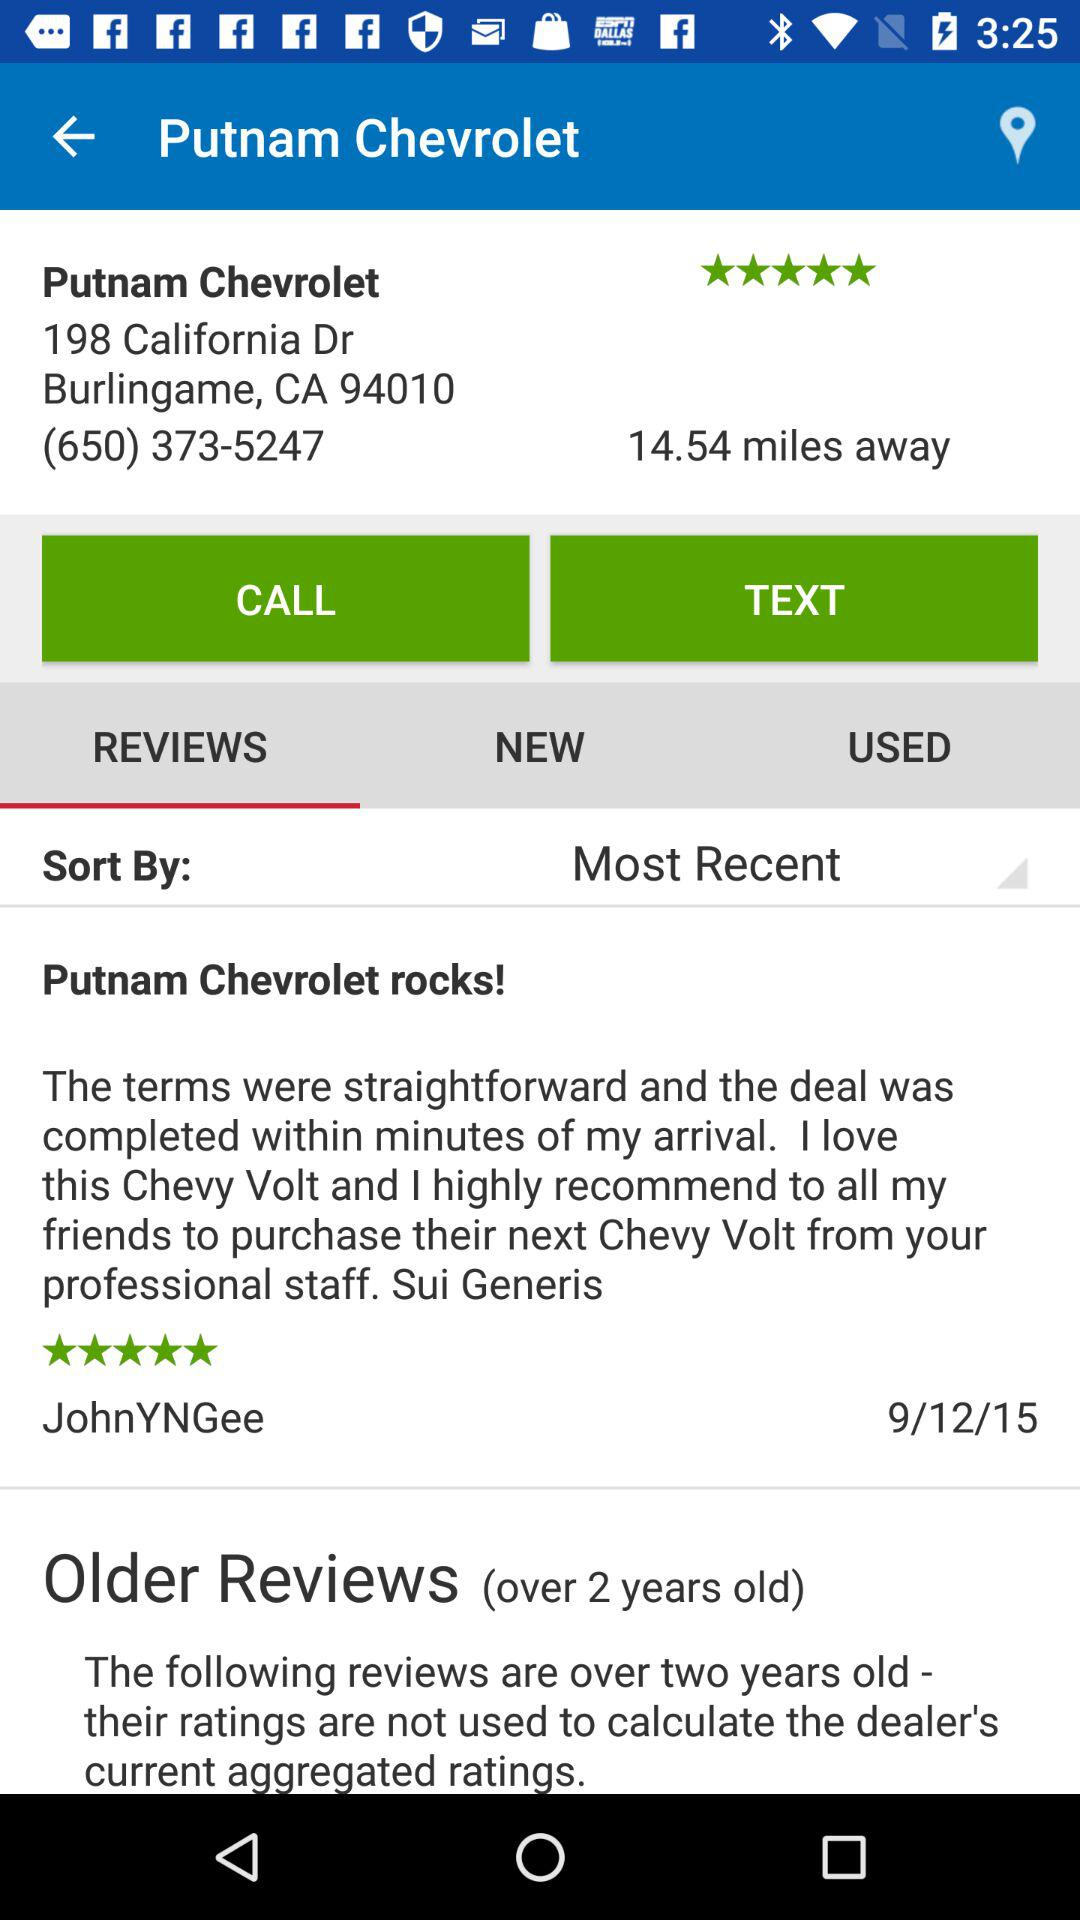What is the location? The location is 198 California Dr Burlingame, CA 94010. 